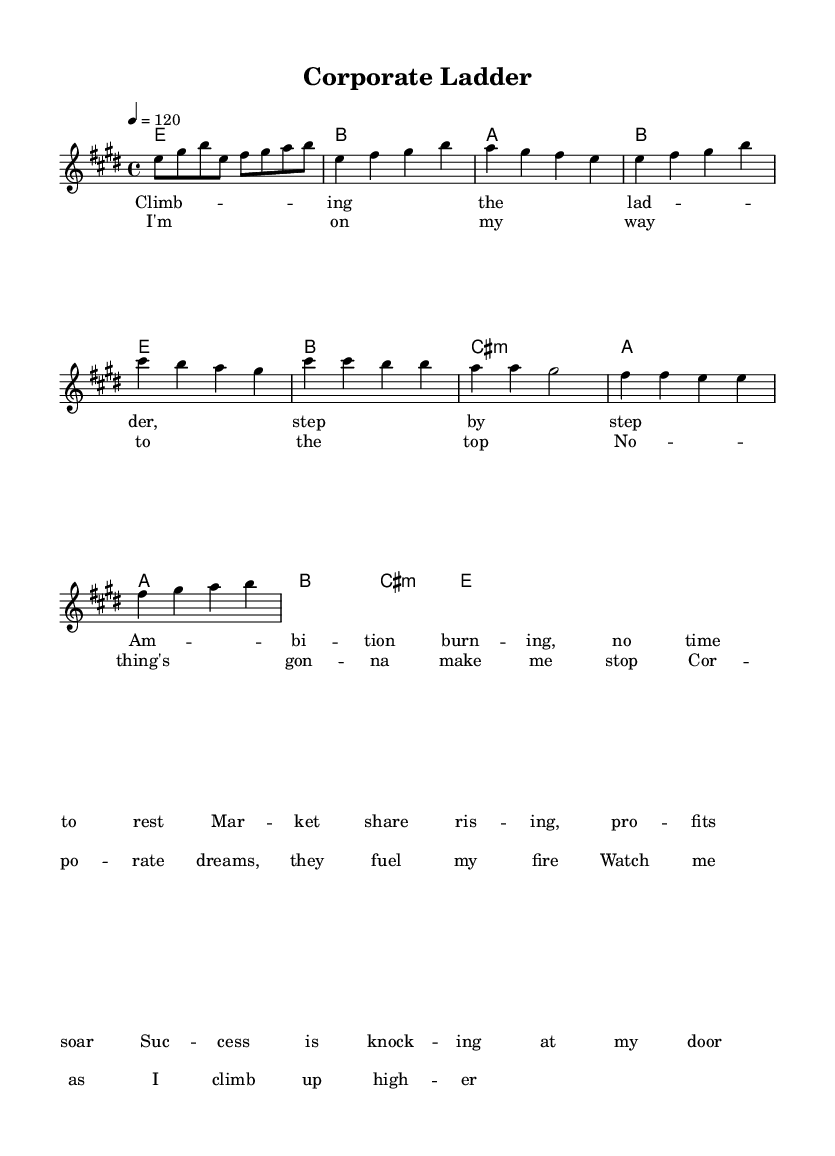What is the key signature of this music? The key signature is E major, which has four sharps (F#, C#, G#, and D#). This can be identified at the beginning of the sheet music where the key signature is indicated.
Answer: E major What is the time signature of this music? The time signature is 4/4, meaning there are four beats in each measure and a quarter note receives one beat. This information is located at the beginning of the score.
Answer: 4/4 What is the tempo marking of the music? The tempo marking is 120 beats per minute, which is specified in the tempo instruction that indicates the speed of the piece.
Answer: 120 How many measures are in the verse section? The verse section consists of four measures, as indicated by counting each line of music notation in the verse part from the score.
Answer: 4 What is the starting note of the chorus? The starting note of the chorus is A, which is evident as it appears first in the melody line when the chorus begins.
Answer: A How does the melody of the chorus differ from the verse? The melody of the chorus is generally higher in pitch and more rhythmic, adding an uplifting quality compared to the verse. This can be analyzed by comparing the specific notes and rhythm patterns in both sections.
Answer: Higher and more rhythmic What lyrical theme does the song convey? The lyrical theme conveys success and ambition, as seen through phrases that highlight climbing up a 'corporate ladder' and achieving 'market share.' This is derived from analyzing the content of the lyrics presented in the score.
Answer: Success and ambition 